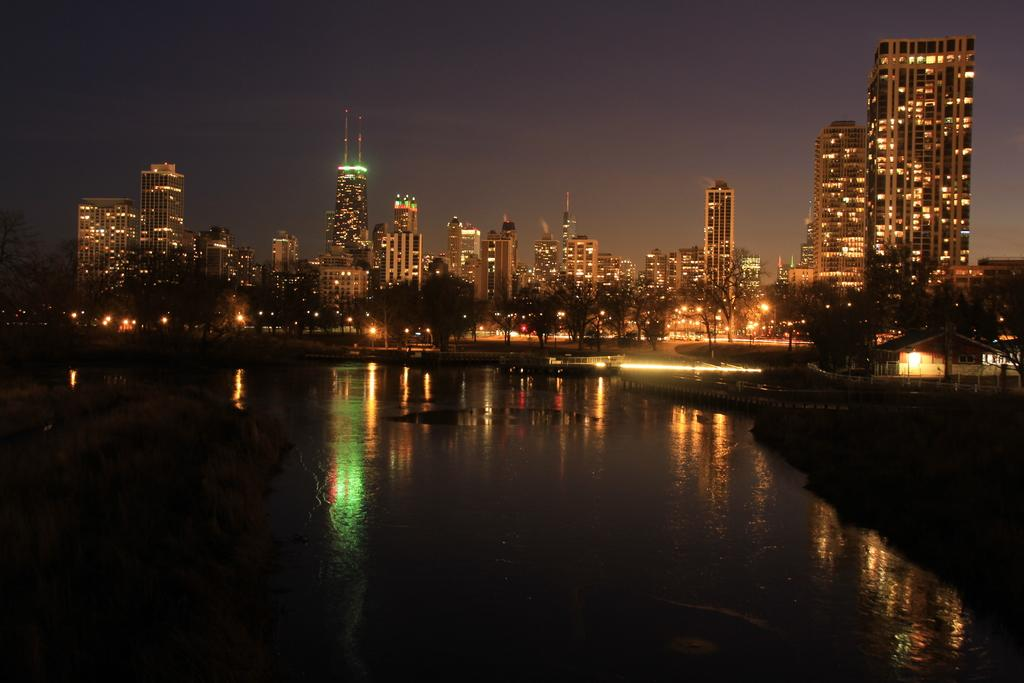What is at the bottom of the image? There is water at the bottom of the image. What can be seen behind the water? There are many trees behind the water. What type of artificial light sources are visible in the image? There are lights visible in the image, including lights on buildings. What type of structures are illuminated by the lights? There are buildings with lights in the image. What is visible at the top of the image? The sky is visible at the top of the image. Can you count the number of toes visible on the trees in the image? There are no toes visible on the trees in the image, as trees do not have toes. 